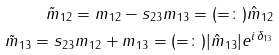Convert formula to latex. <formula><loc_0><loc_0><loc_500><loc_500>\tilde { m } _ { 1 2 } = m _ { 1 2 } - s _ { 2 3 } m _ { 1 3 } = ( = \colon ) \hat { m } _ { 1 2 } \\ \tilde { m } _ { 1 3 } = s _ { 2 3 } m _ { 1 2 } + m _ { 1 3 } = ( = \colon ) | \hat { m } _ { 1 3 } | e ^ { i \, \delta _ { 1 3 } }</formula> 